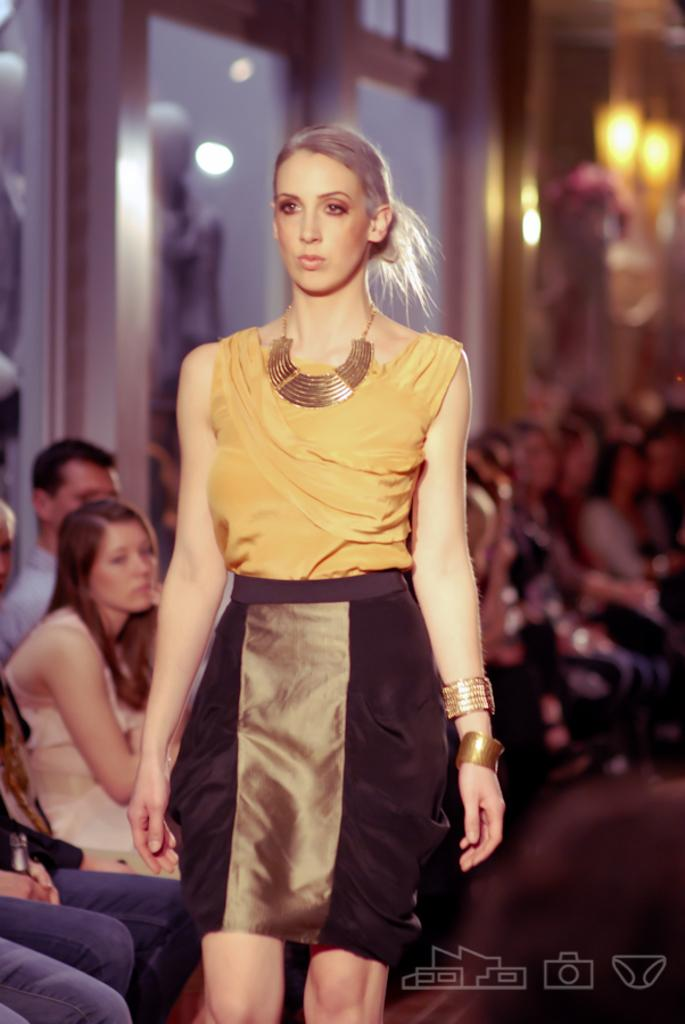What is the woman in the image doing? The woman is standing on a ramp in the image. Can you describe the background of the image? There are people sitting on chairs in the background of the image. What type of clouds can be seen in the image? There are no clouds visible in the image. How many pizzas are being served to the people sitting on chairs in the image? There is no mention of pizzas or any food in the image. 